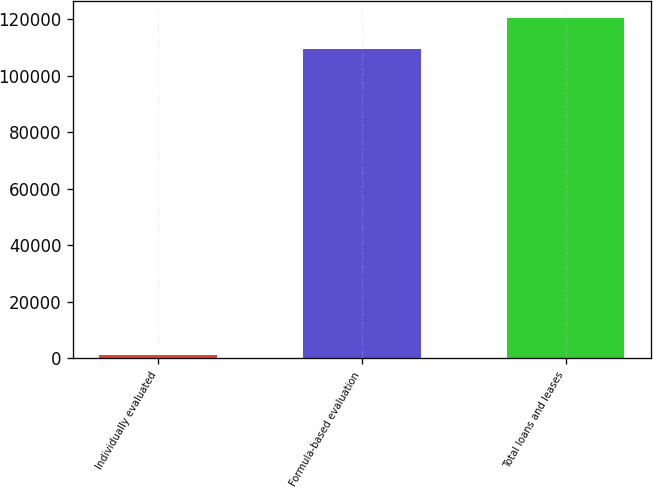Convert chart. <chart><loc_0><loc_0><loc_500><loc_500><bar_chart><fcel>Individually evaluated<fcel>Formula-based evaluation<fcel>Total loans and leases<nl><fcel>1131<fcel>109486<fcel>120435<nl></chart> 